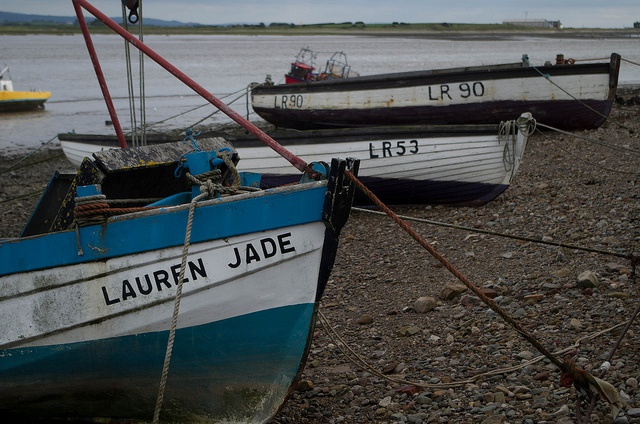Describe the objects in this image and their specific colors. I can see boat in gray, black, and blue tones, boat in gray and black tones, boat in gray, black, and darkgray tones, and boat in gray, black, tan, darkgray, and orange tones in this image. 